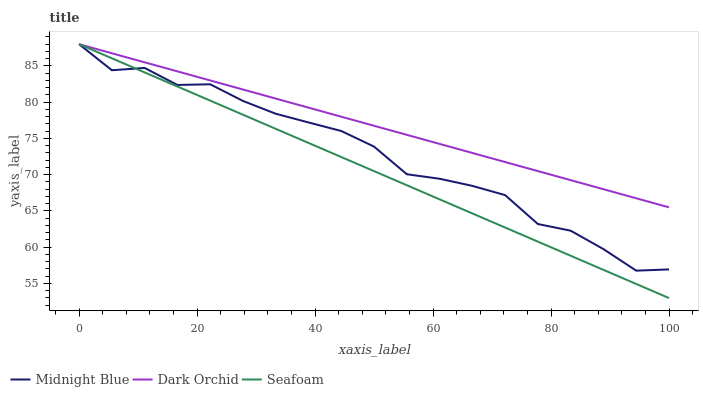Does Seafoam have the minimum area under the curve?
Answer yes or no. Yes. Does Dark Orchid have the maximum area under the curve?
Answer yes or no. Yes. Does Dark Orchid have the minimum area under the curve?
Answer yes or no. No. Does Seafoam have the maximum area under the curve?
Answer yes or no. No. Is Seafoam the smoothest?
Answer yes or no. Yes. Is Midnight Blue the roughest?
Answer yes or no. Yes. Is Dark Orchid the smoothest?
Answer yes or no. No. Is Dark Orchid the roughest?
Answer yes or no. No. Does Seafoam have the lowest value?
Answer yes or no. Yes. Does Dark Orchid have the lowest value?
Answer yes or no. No. Does Seafoam have the highest value?
Answer yes or no. Yes. Does Dark Orchid intersect Midnight Blue?
Answer yes or no. Yes. Is Dark Orchid less than Midnight Blue?
Answer yes or no. No. Is Dark Orchid greater than Midnight Blue?
Answer yes or no. No. 